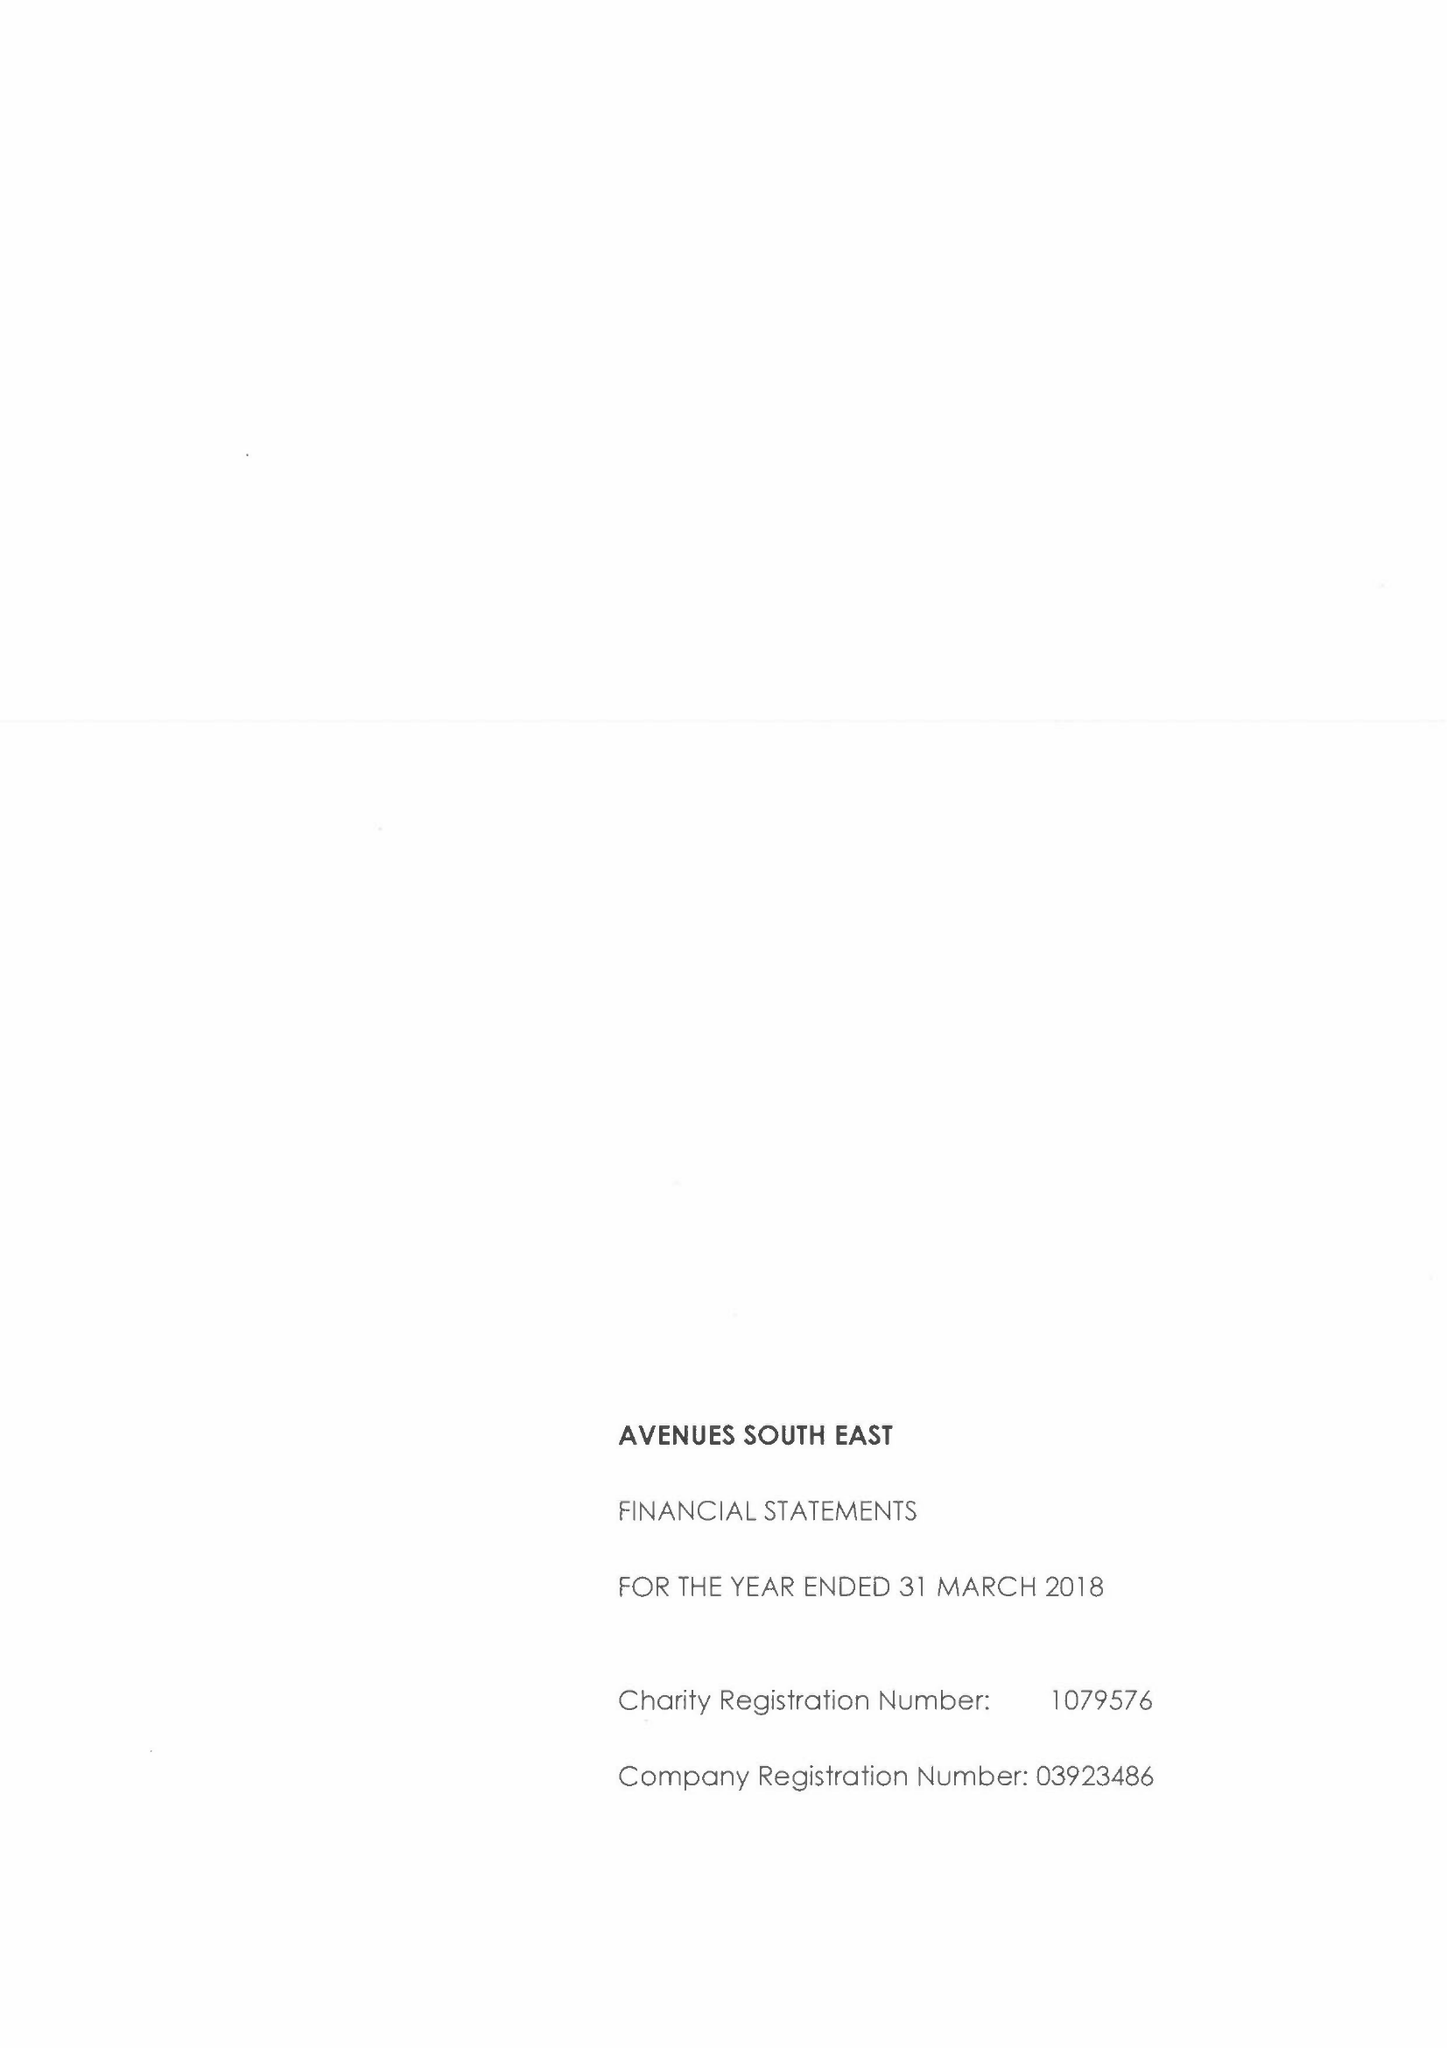What is the value for the charity_number?
Answer the question using a single word or phrase. 1079576 